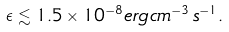<formula> <loc_0><loc_0><loc_500><loc_500>\epsilon \lesssim 1 . 5 \times 1 0 ^ { - 8 } e r g \, c m ^ { - 3 } \, s ^ { - 1 } .</formula> 